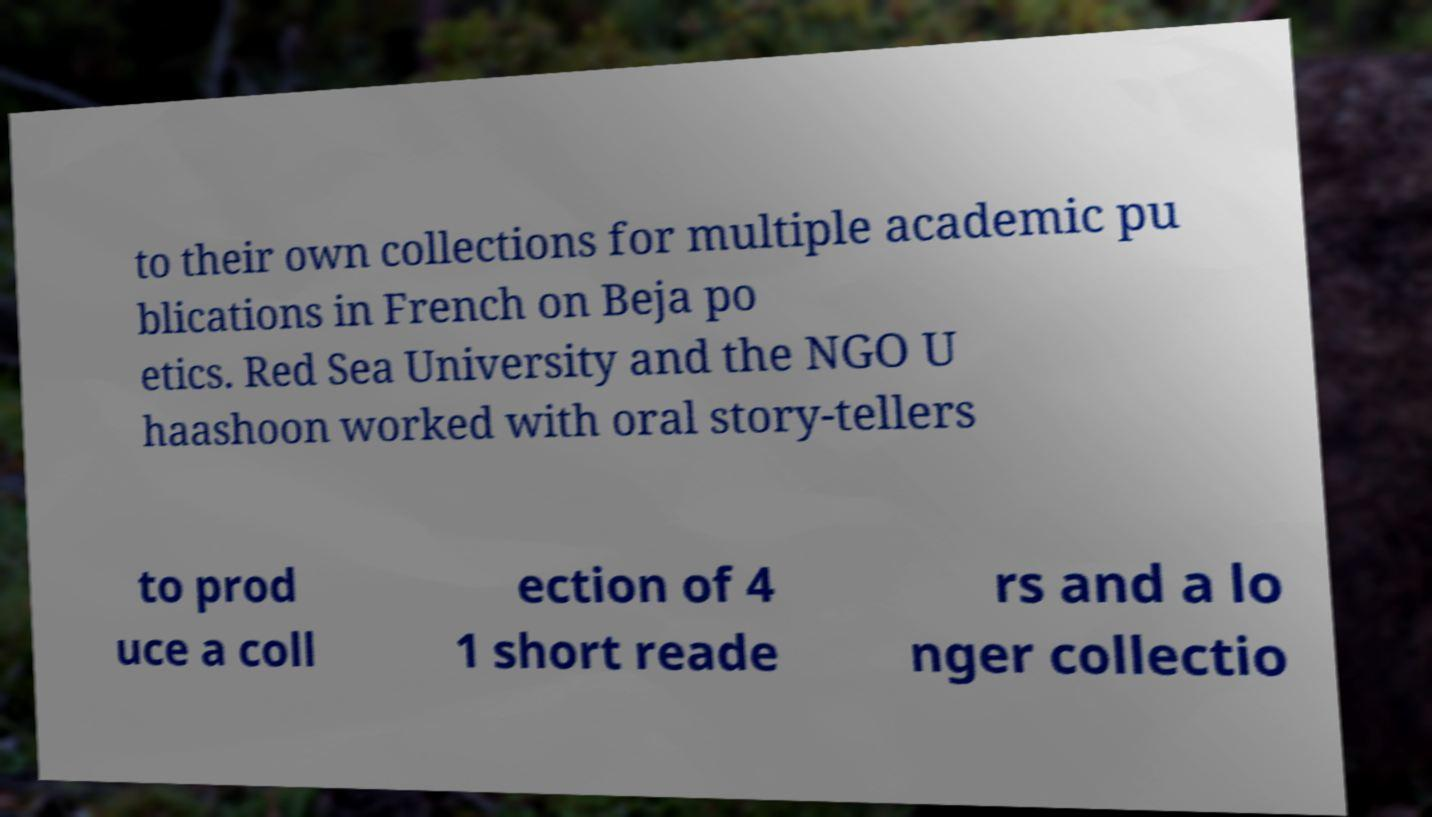Can you accurately transcribe the text from the provided image for me? to their own collections for multiple academic pu blications in French on Beja po etics. Red Sea University and the NGO U haashoon worked with oral story-tellers to prod uce a coll ection of 4 1 short reade rs and a lo nger collectio 